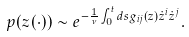<formula> <loc_0><loc_0><loc_500><loc_500>p ( z ( \cdot ) ) \sim e ^ { - \frac { 1 } { \nu } \int _ { 0 } ^ { t } d s g _ { i j } ( z ) \dot { z } ^ { i } \dot { z } ^ { j } } .</formula> 